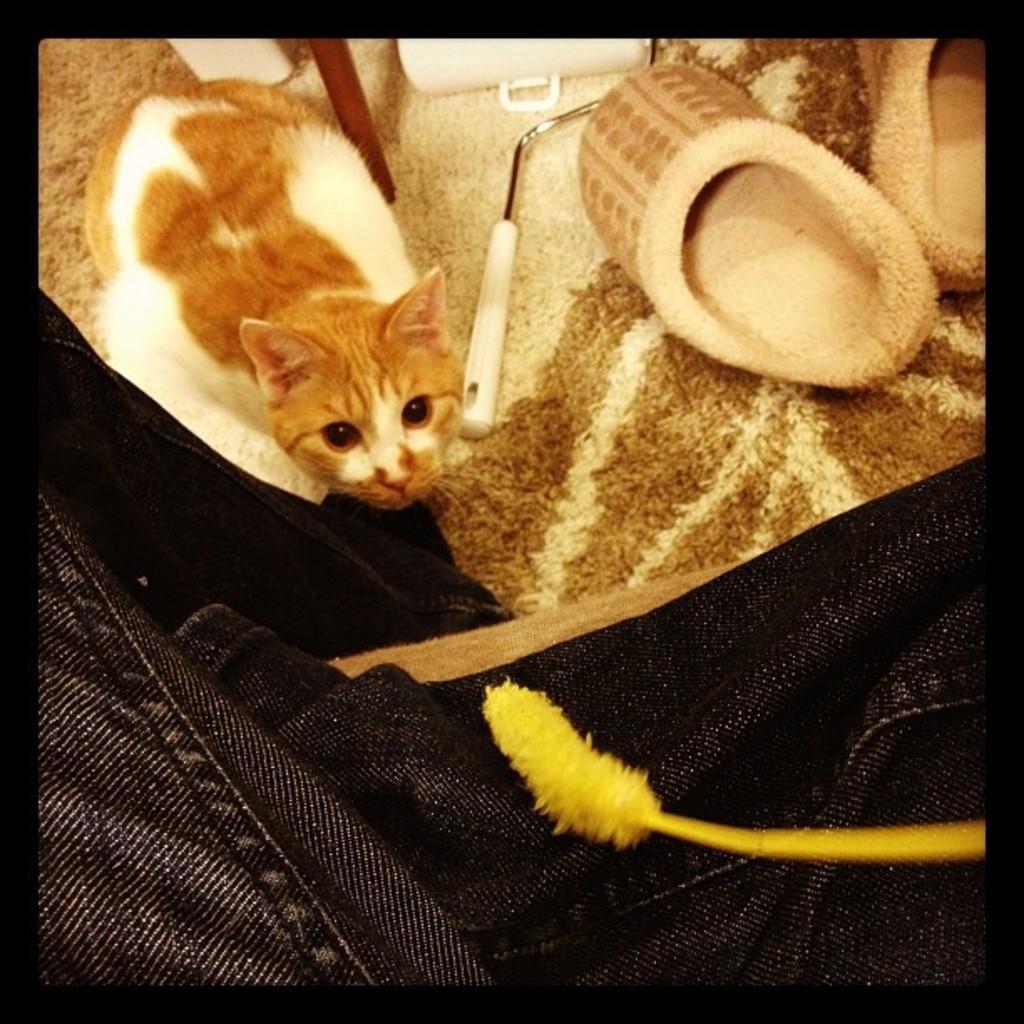Can you describe this image briefly? In this image I can see a cat. The cat is in brown and white color and I can also see few objects on the cream and brown color surface. 